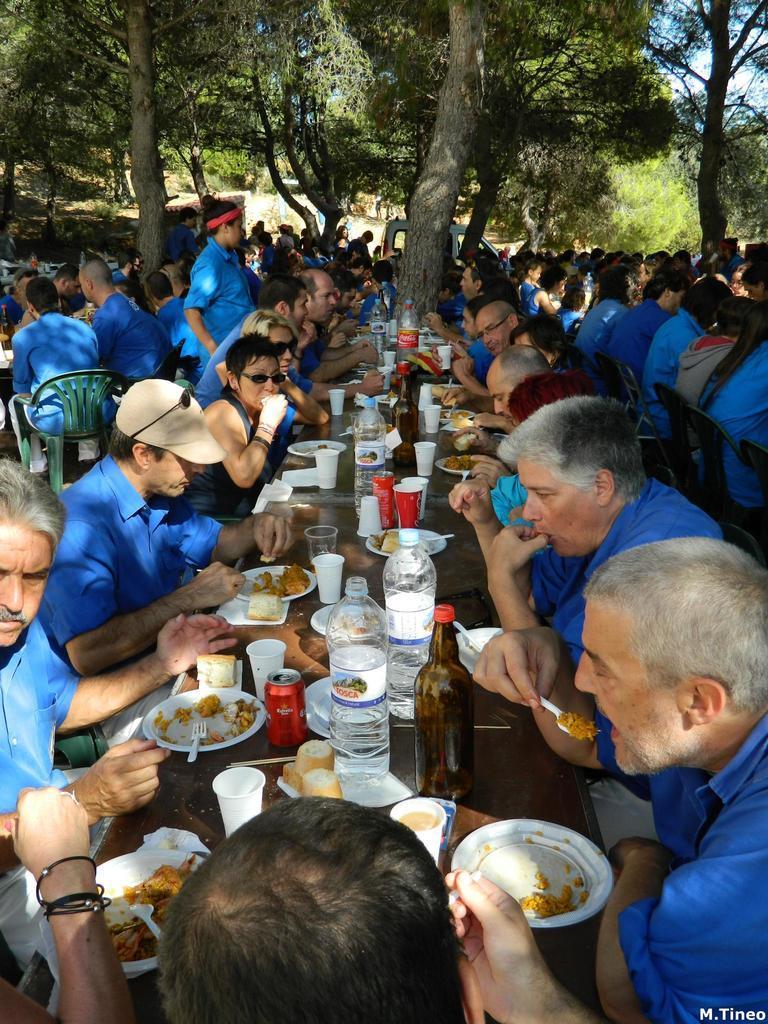Please provide a concise description of this image. In this picture we can see a group of people sitting on chairs and in front of them on tables we can see bottles, glasses, plates with food items on it, forks and in the background we can see a vehicle, trees, sky. 